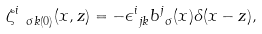Convert formula to latex. <formula><loc_0><loc_0><loc_500><loc_500>\zeta ^ { i } _ { \ \sigma k ( 0 ) } ( x , z ) & = - \epsilon ^ { i } _ { \ j k } b ^ { j } _ { \ \sigma } ( x ) \delta ( { x } - { z } ) , \\</formula> 